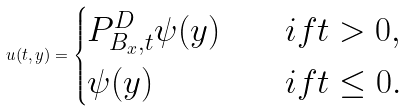Convert formula to latex. <formula><loc_0><loc_0><loc_500><loc_500>u ( t , y ) = \begin{cases} P ^ { D } _ { B _ { x } , t } \psi ( y ) \quad & i f t > 0 , \\ \psi ( y ) & i f t \leq 0 . \end{cases}</formula> 